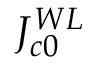<formula> <loc_0><loc_0><loc_500><loc_500>J _ { c 0 } ^ { W L }</formula> 